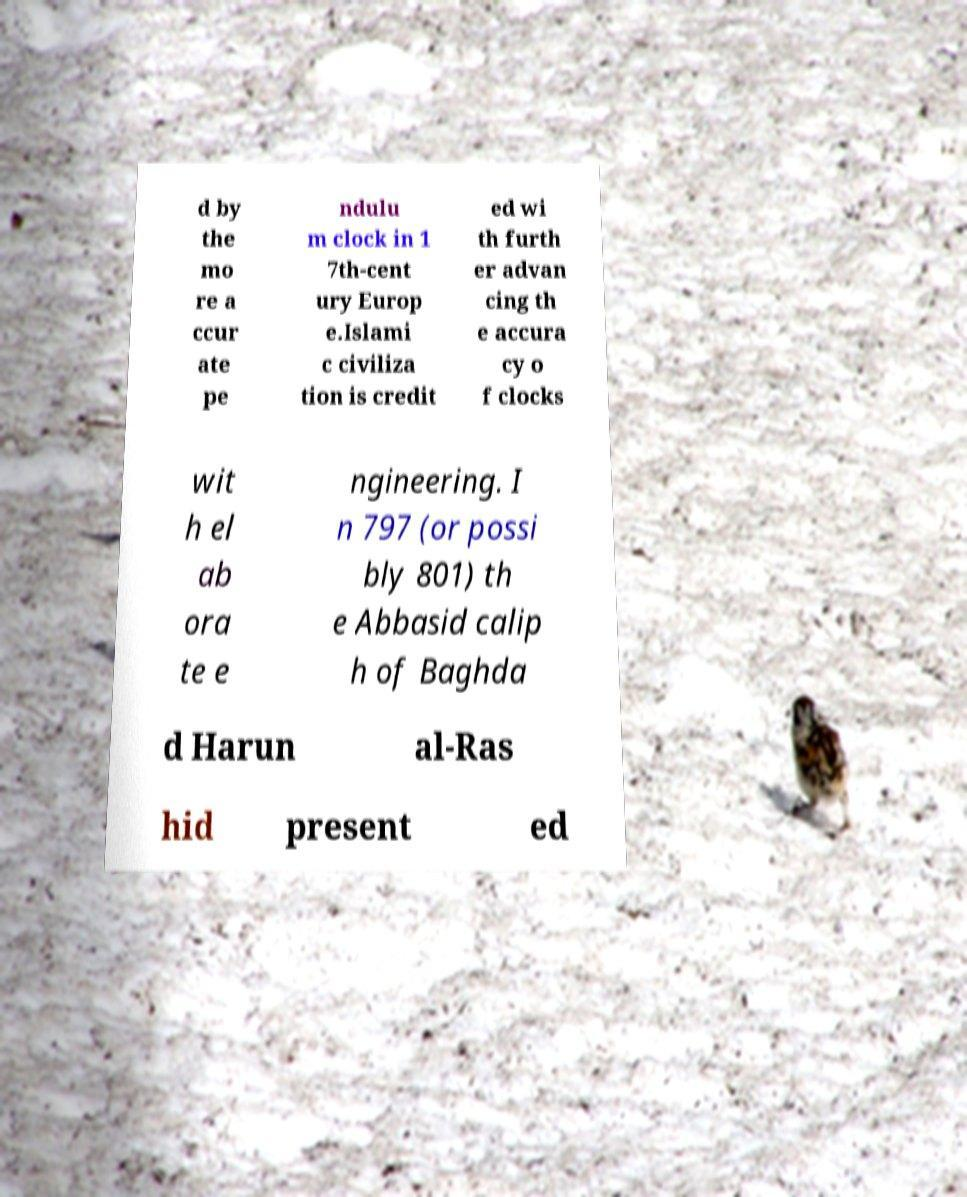Could you extract and type out the text from this image? d by the mo re a ccur ate pe ndulu m clock in 1 7th-cent ury Europ e.Islami c civiliza tion is credit ed wi th furth er advan cing th e accura cy o f clocks wit h el ab ora te e ngineering. I n 797 (or possi bly 801) th e Abbasid calip h of Baghda d Harun al-Ras hid present ed 